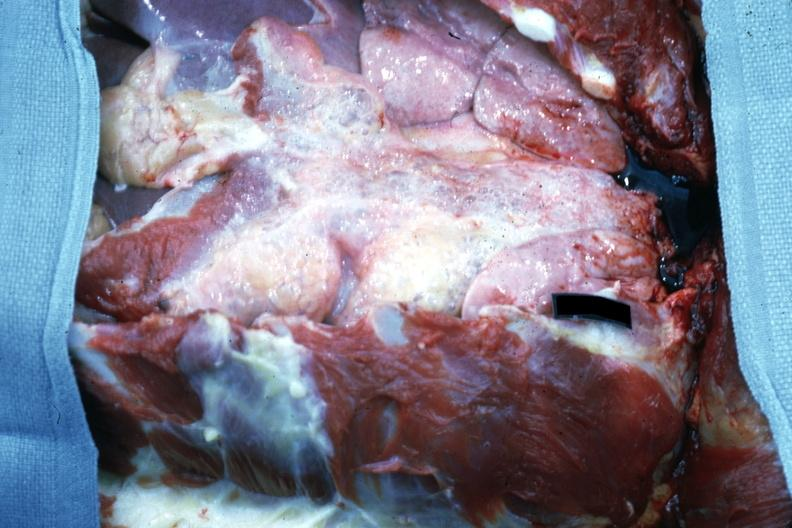what is present?
Answer the question using a single word or phrase. Emphysema 